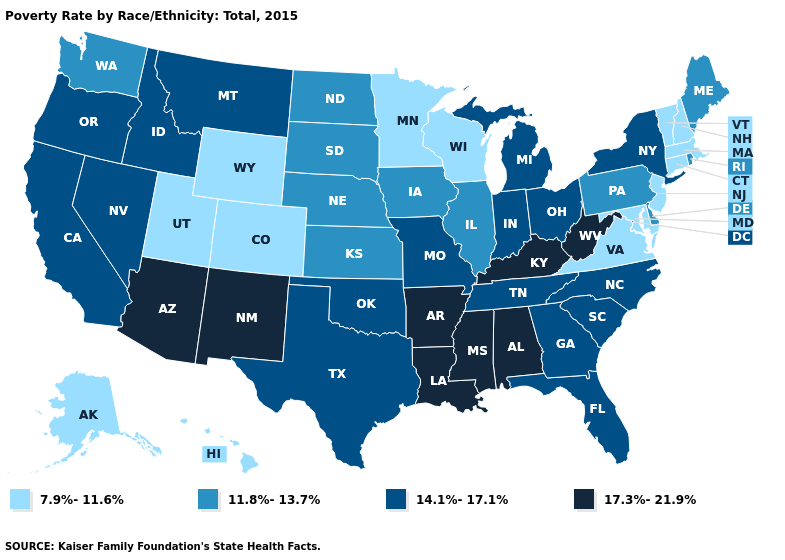What is the highest value in the West ?
Short answer required. 17.3%-21.9%. Which states hav the highest value in the MidWest?
Keep it brief. Indiana, Michigan, Missouri, Ohio. Does Alaska have a lower value than Illinois?
Short answer required. Yes. What is the highest value in the USA?
Concise answer only. 17.3%-21.9%. What is the value of Alabama?
Short answer required. 17.3%-21.9%. Name the states that have a value in the range 17.3%-21.9%?
Give a very brief answer. Alabama, Arizona, Arkansas, Kentucky, Louisiana, Mississippi, New Mexico, West Virginia. Which states have the lowest value in the MidWest?
Give a very brief answer. Minnesota, Wisconsin. What is the value of West Virginia?
Keep it brief. 17.3%-21.9%. What is the value of New Jersey?
Answer briefly. 7.9%-11.6%. What is the value of Kentucky?
Quick response, please. 17.3%-21.9%. How many symbols are there in the legend?
Be succinct. 4. Does the first symbol in the legend represent the smallest category?
Keep it brief. Yes. Does Illinois have the same value as Kansas?
Answer briefly. Yes. What is the lowest value in the West?
Answer briefly. 7.9%-11.6%. Does Virginia have a higher value than Massachusetts?
Be succinct. No. 